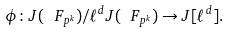Convert formula to latex. <formula><loc_0><loc_0><loc_500><loc_500>\phi \colon J ( \ F _ { p ^ { k } } ) / \ell ^ { d } J ( \ F _ { p ^ { k } } ) \to J [ \ell ^ { d } ] .</formula> 